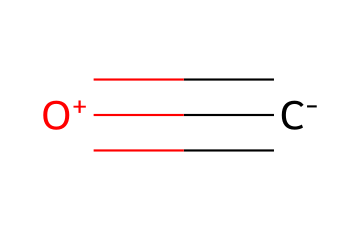What is the total number of atoms in carbon monoxide? The molecular structure of carbon monoxide consists of one carbon atom and one oxygen atom, giving a total of two atoms in the molecule.
Answer: 2 How many bonds are present between the carbon and oxygen in this compound? The SMILES representation shows a triple bond between the carbon and oxygen as indicated by the "#" symbol, therefore there are three bonds in total.
Answer: 3 What is the primary type of bonding in carbon monoxide? The triple bond observed in carbon monoxide indicates that it is primarily covalent bonding, where atoms share electrons.
Answer: covalent What is the formal charge on the oxygen atom in carbon monoxide? In the structure, oxygen carries a positive charge as indicated by the "[O+]" part of the SMILES, meaning the formal charge is +1.
Answer: +1 What is the molecular geometry of carbon monoxide? Carbon monoxide has a linear molecular geometry due to the triple bond between carbon and oxygen, which pulls the two atoms in a straight line arrangement.
Answer: linear Is carbon monoxide a toxic gas, and if so, why? Carbon monoxide is indeed a toxic gas because it can bind strongly to hemoglobin in blood, preventing oxygen transport, which can lead to suffocation.
Answer: yes 